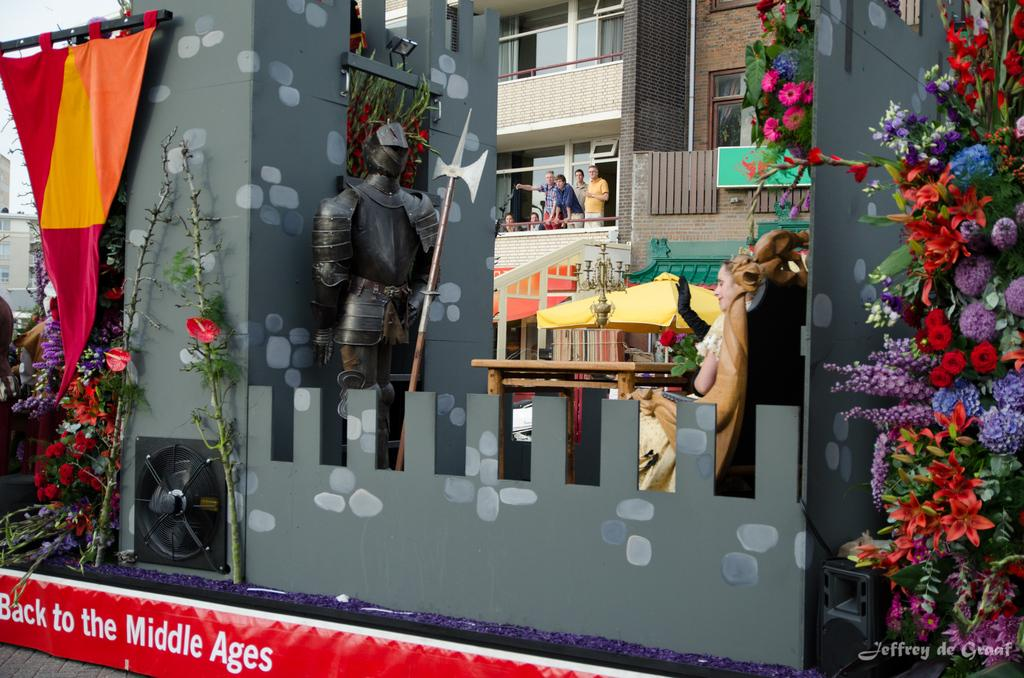<image>
Present a compact description of the photo's key features. back to the middle ages parade float with a woman on it 